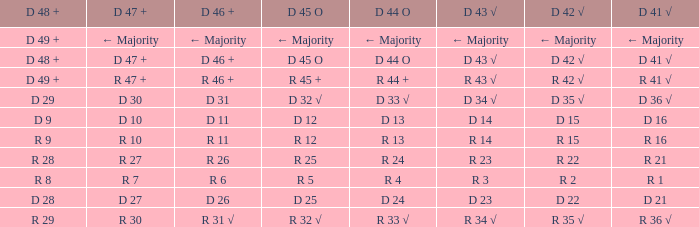What is the value of D 43 √ when the value of D 42 √ is d 42 √? D 43 √. 